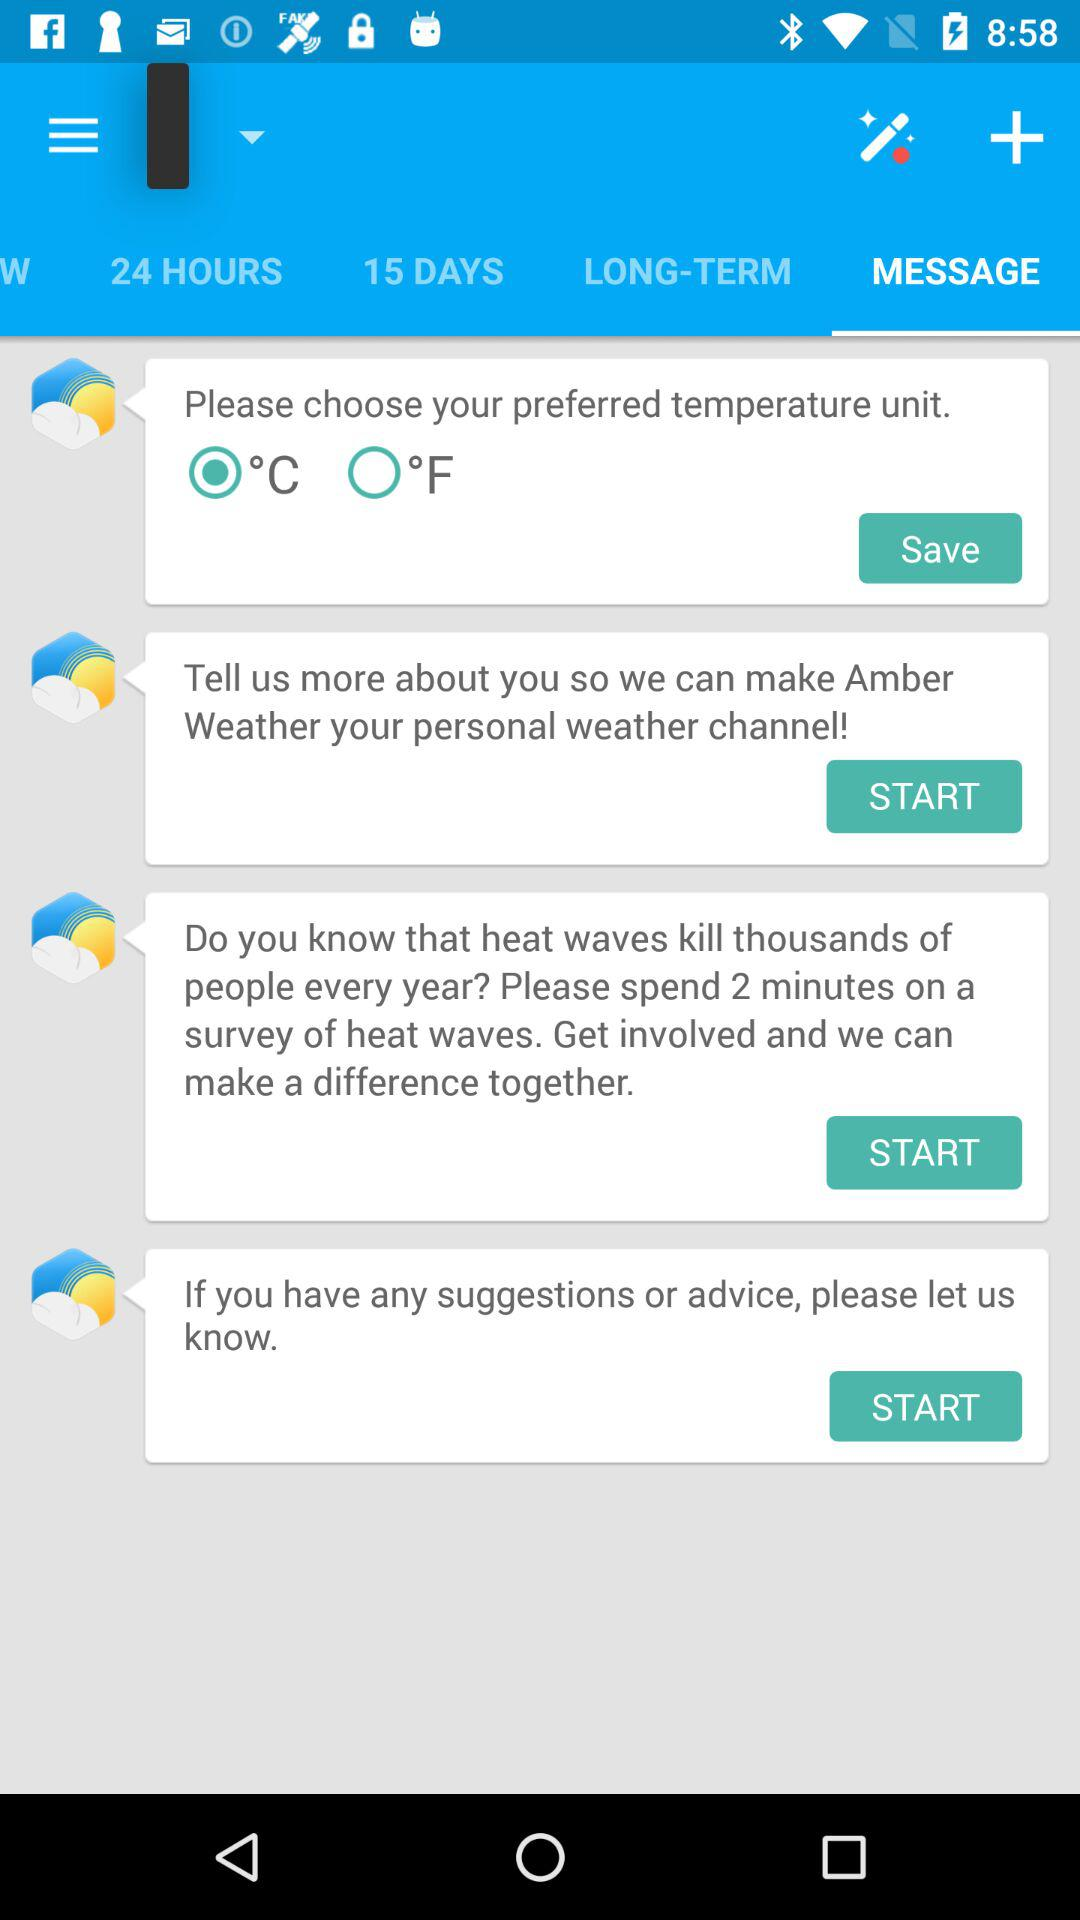What is the temperature unit? The temperature unit is °C. 